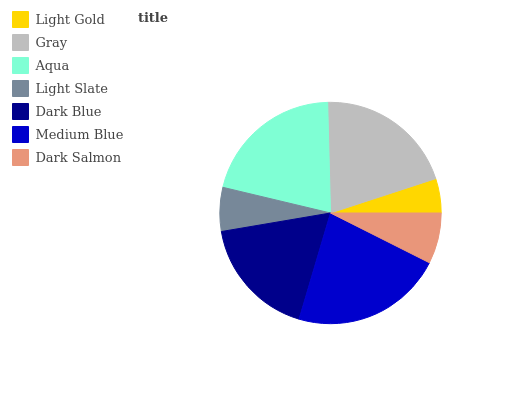Is Light Gold the minimum?
Answer yes or no. Yes. Is Medium Blue the maximum?
Answer yes or no. Yes. Is Gray the minimum?
Answer yes or no. No. Is Gray the maximum?
Answer yes or no. No. Is Gray greater than Light Gold?
Answer yes or no. Yes. Is Light Gold less than Gray?
Answer yes or no. Yes. Is Light Gold greater than Gray?
Answer yes or no. No. Is Gray less than Light Gold?
Answer yes or no. No. Is Dark Blue the high median?
Answer yes or no. Yes. Is Dark Blue the low median?
Answer yes or no. Yes. Is Gray the high median?
Answer yes or no. No. Is Gray the low median?
Answer yes or no. No. 